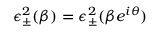Convert formula to latex. <formula><loc_0><loc_0><loc_500><loc_500>\epsilon _ { \pm } ^ { 2 } ( \beta ) = \epsilon _ { \pm } ^ { 2 } ( \beta e ^ { i \theta } )</formula> 